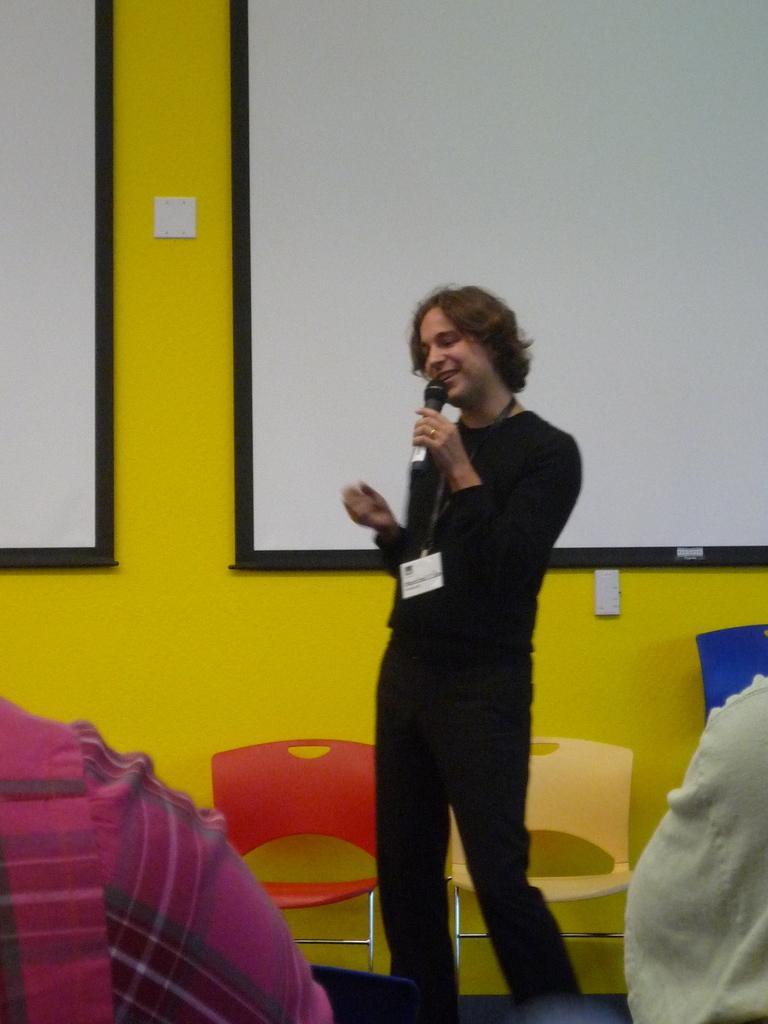How would you summarize this image in a sentence or two? Bottom of the image few people are sitting. In the middle of the image a person is standing and holding a microphone and smiling. Behind the person there are some chairs and there is a wall, on the wall there are some banners. 